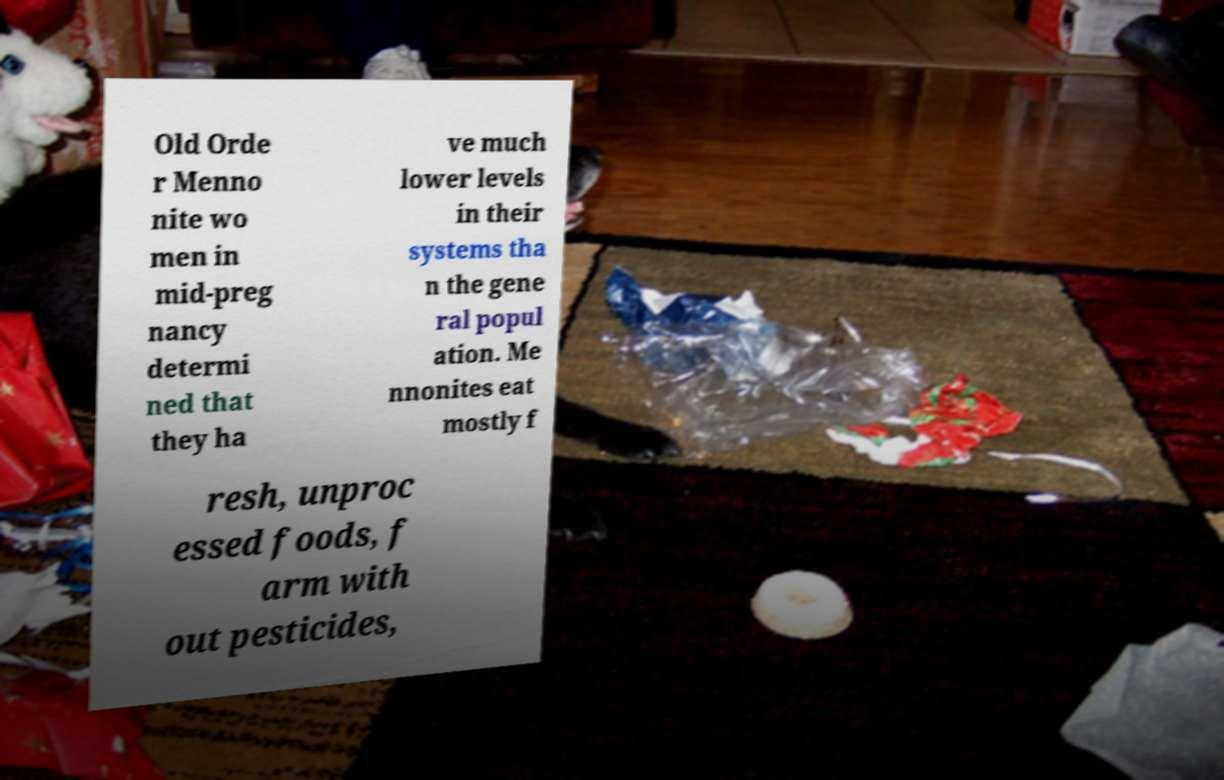There's text embedded in this image that I need extracted. Can you transcribe it verbatim? Old Orde r Menno nite wo men in mid-preg nancy determi ned that they ha ve much lower levels in their systems tha n the gene ral popul ation. Me nnonites eat mostly f resh, unproc essed foods, f arm with out pesticides, 